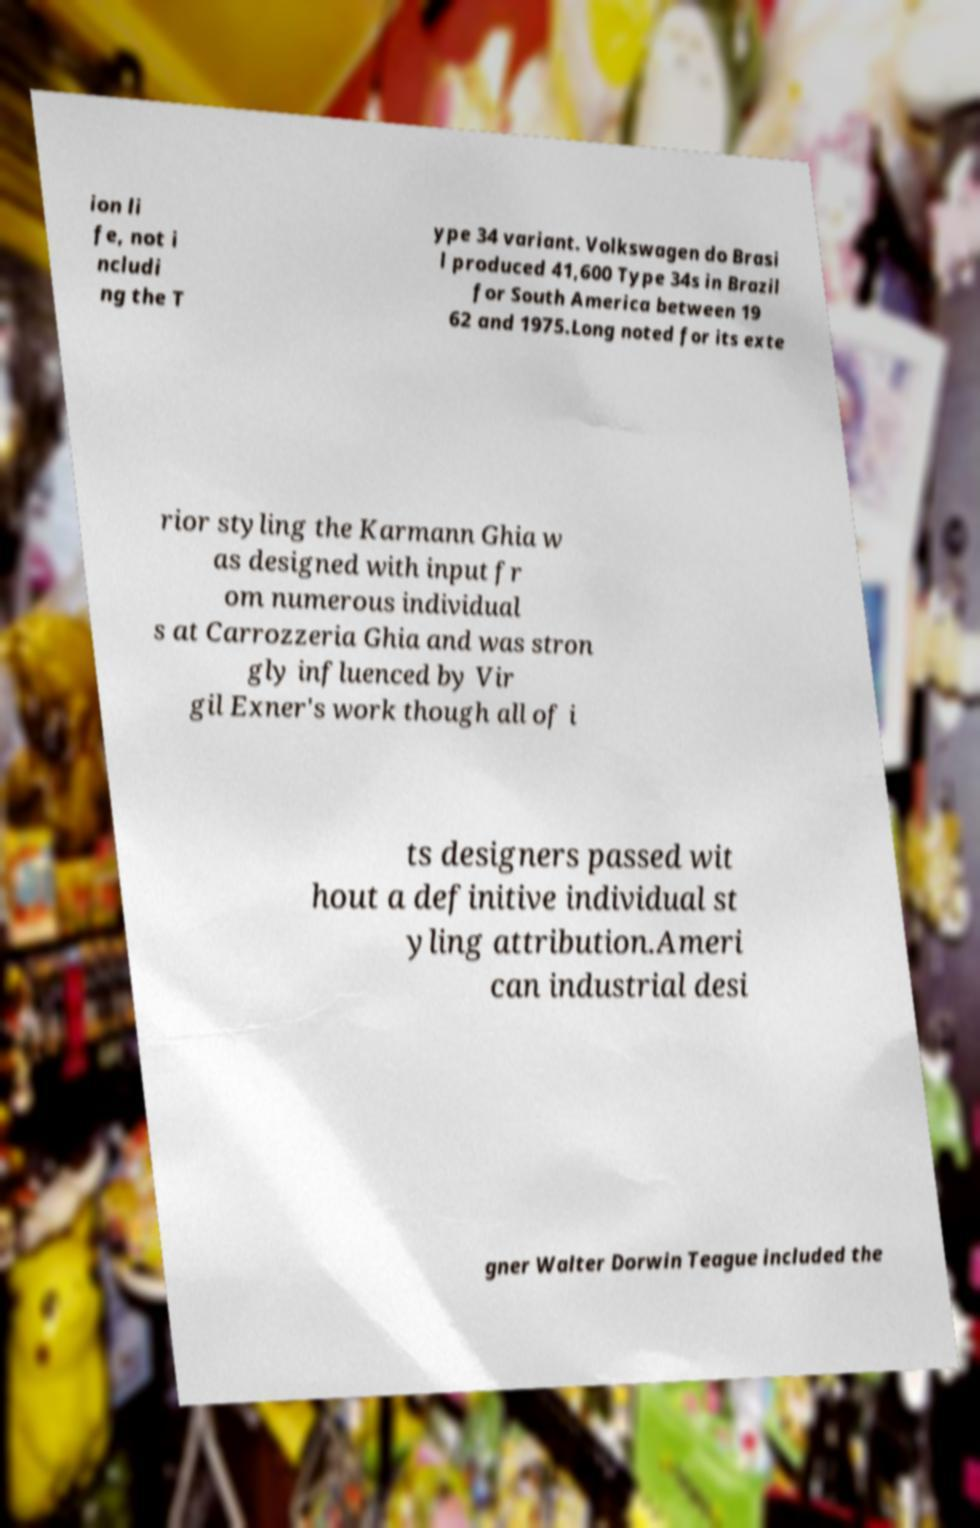Please read and relay the text visible in this image. What does it say? ion li fe, not i ncludi ng the T ype 34 variant. Volkswagen do Brasi l produced 41,600 Type 34s in Brazil for South America between 19 62 and 1975.Long noted for its exte rior styling the Karmann Ghia w as designed with input fr om numerous individual s at Carrozzeria Ghia and was stron gly influenced by Vir gil Exner's work though all of i ts designers passed wit hout a definitive individual st yling attribution.Ameri can industrial desi gner Walter Dorwin Teague included the 